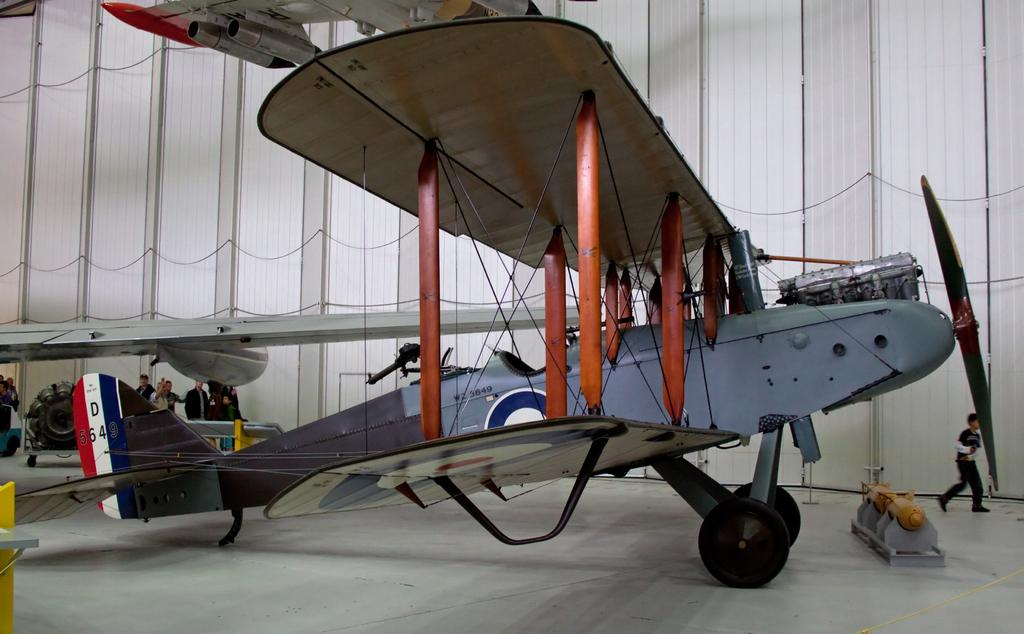What is the main subject of the image? The main subject of the image is an airplane. What can be seen on the floor in the image? There are objects on the floor in the image. What are the people in the image doing? The people in the image are standing and walking. What is visible in the background of the image? There is a wall in the background of the image. What type of organization is responsible for the airplane's maintenance in the image? There is no information about the organization responsible for the airplane's maintenance in the image. Can you see the tongue of the person walking in the image? There is no tongue visible in the image. 